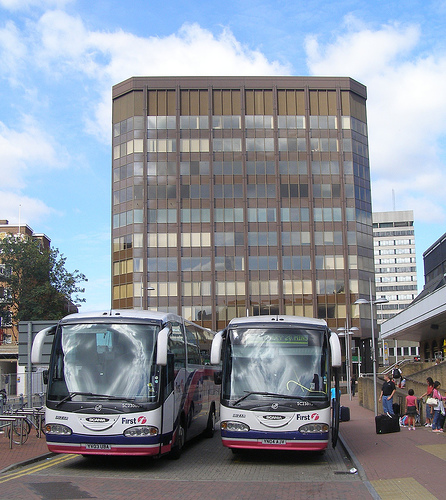Which side are the people on? The people are predominantly on the right side of the image, standing near the buses. 